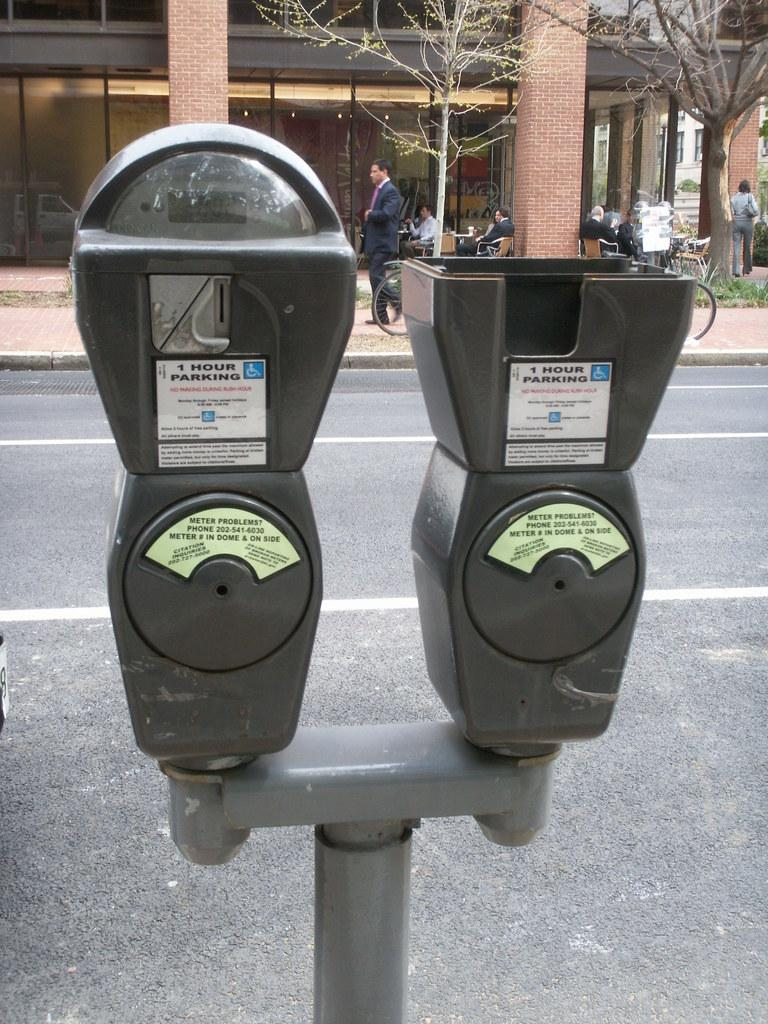<image>
Provide a brief description of the given image. Meter that have one hour parking and a handicapped sign 